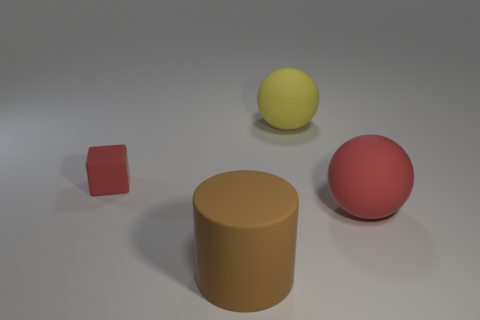Is the shape of the tiny object the same as the brown rubber object?
Provide a short and direct response. No. What color is the cylinder that is made of the same material as the cube?
Provide a short and direct response. Brown. How many things are matte things that are behind the big brown matte thing or tiny brown metal balls?
Your response must be concise. 3. There is a red object to the right of the yellow object; what size is it?
Provide a succinct answer. Large. Does the yellow rubber object have the same size as the red thing that is right of the large brown cylinder?
Make the answer very short. Yes. What color is the ball in front of the yellow rubber thing that is behind the red cube?
Make the answer very short. Red. How many other objects are the same color as the tiny thing?
Give a very brief answer. 1. The brown matte cylinder has what size?
Offer a terse response. Large. Are there more big brown rubber cylinders in front of the cylinder than rubber spheres behind the yellow matte sphere?
Ensure brevity in your answer.  No. There is a red matte object on the right side of the large yellow ball; how many matte balls are on the left side of it?
Offer a very short reply. 1. 